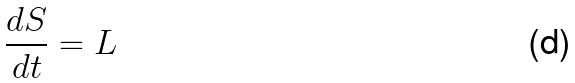<formula> <loc_0><loc_0><loc_500><loc_500>\frac { d S } { d t } = L</formula> 